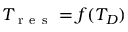<formula> <loc_0><loc_0><loc_500><loc_500>T _ { r e s } = f ( T _ { D } )</formula> 